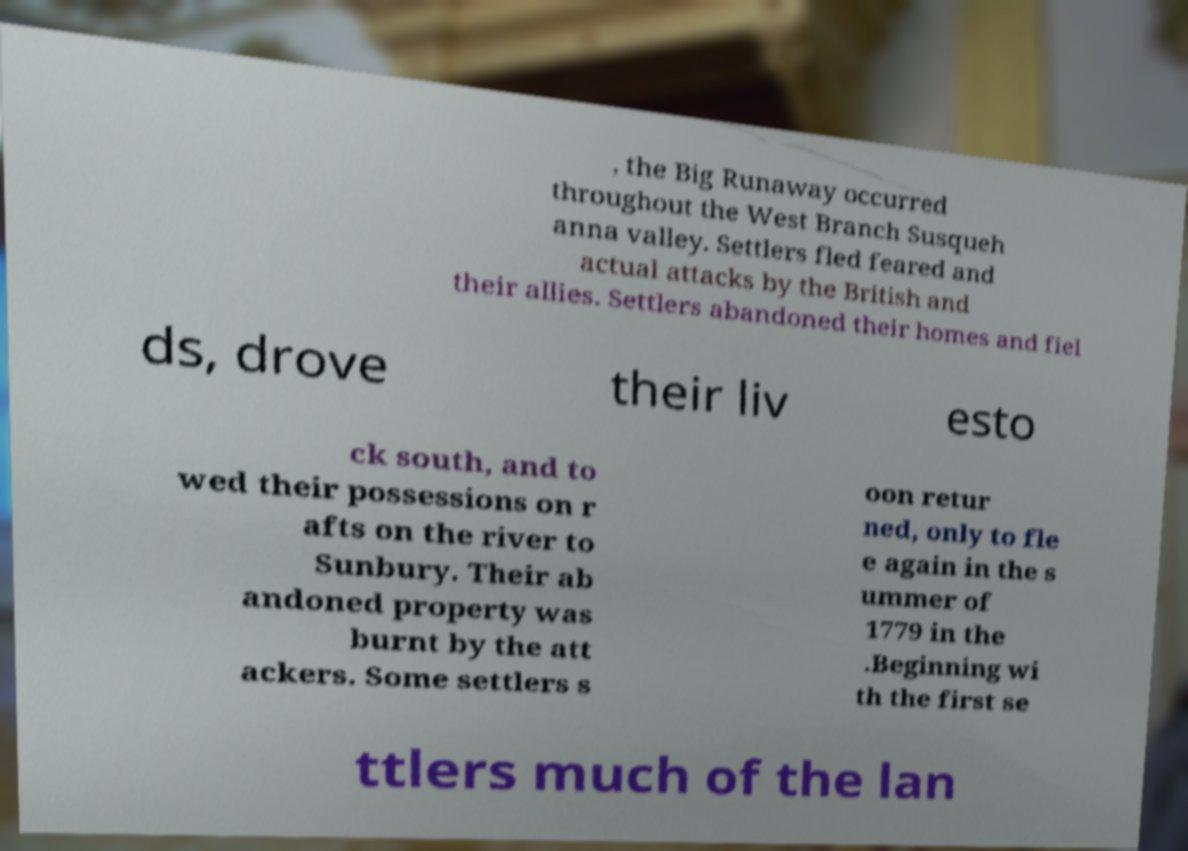Can you read and provide the text displayed in the image?This photo seems to have some interesting text. Can you extract and type it out for me? , the Big Runaway occurred throughout the West Branch Susqueh anna valley. Settlers fled feared and actual attacks by the British and their allies. Settlers abandoned their homes and fiel ds, drove their liv esto ck south, and to wed their possessions on r afts on the river to Sunbury. Their ab andoned property was burnt by the att ackers. Some settlers s oon retur ned, only to fle e again in the s ummer of 1779 in the .Beginning wi th the first se ttlers much of the lan 